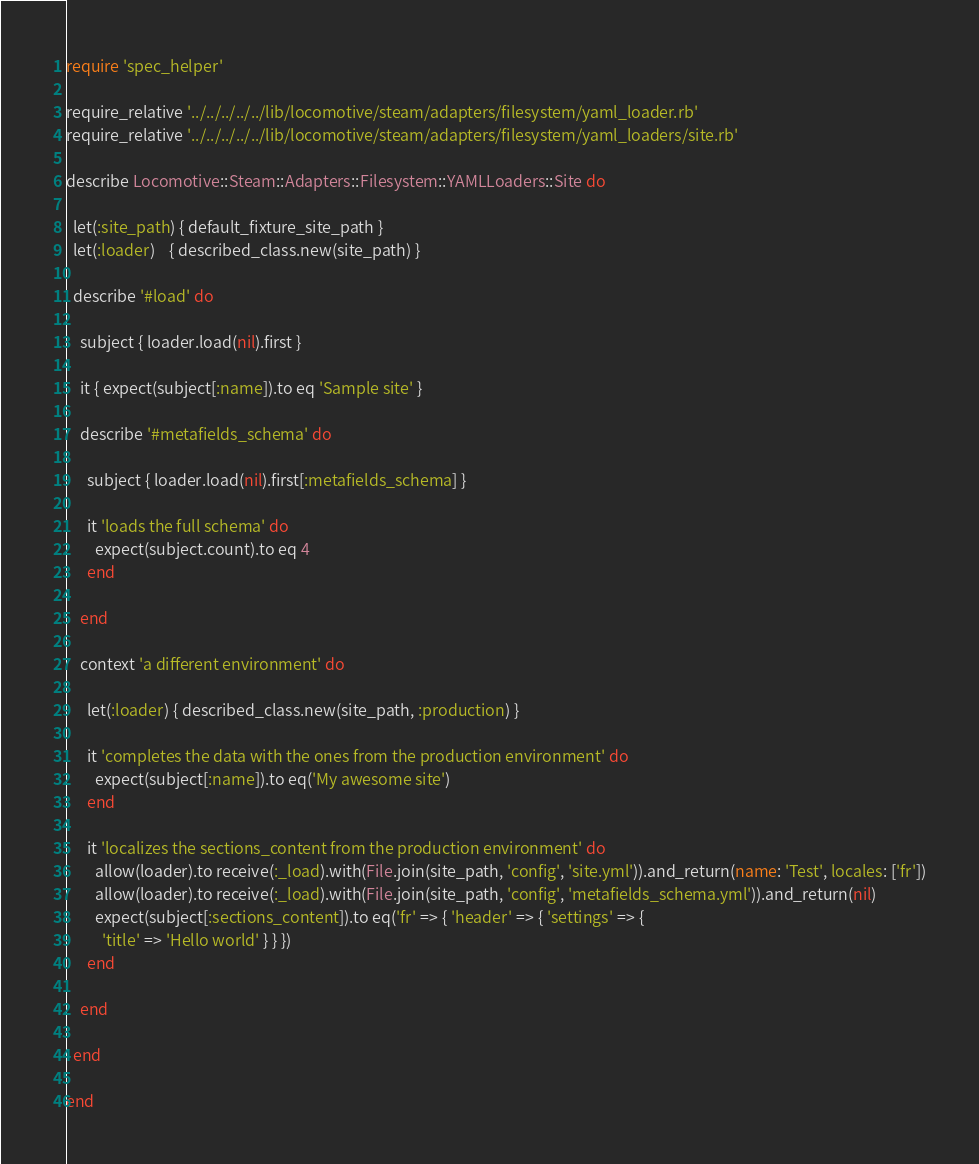<code> <loc_0><loc_0><loc_500><loc_500><_Ruby_>require 'spec_helper'

require_relative '../../../../../lib/locomotive/steam/adapters/filesystem/yaml_loader.rb'
require_relative '../../../../../lib/locomotive/steam/adapters/filesystem/yaml_loaders/site.rb'

describe Locomotive::Steam::Adapters::Filesystem::YAMLLoaders::Site do

  let(:site_path) { default_fixture_site_path }
  let(:loader)    { described_class.new(site_path) }

  describe '#load' do

    subject { loader.load(nil).first }

    it { expect(subject[:name]).to eq 'Sample site' }

    describe '#metafields_schema' do

      subject { loader.load(nil).first[:metafields_schema] }

      it 'loads the full schema' do
        expect(subject.count).to eq 4
      end

    end

    context 'a different environment' do

      let(:loader) { described_class.new(site_path, :production) }

      it 'completes the data with the ones from the production environment' do
        expect(subject[:name]).to eq('My awesome site')
      end

      it 'localizes the sections_content from the production environment' do
        allow(loader).to receive(:_load).with(File.join(site_path, 'config', 'site.yml')).and_return(name: 'Test', locales: ['fr'])
        allow(loader).to receive(:_load).with(File.join(site_path, 'config', 'metafields_schema.yml')).and_return(nil)
        expect(subject[:sections_content]).to eq('fr' => { 'header' => { 'settings' => {
          'title' => 'Hello world' } } })
      end

    end

  end

end
</code> 